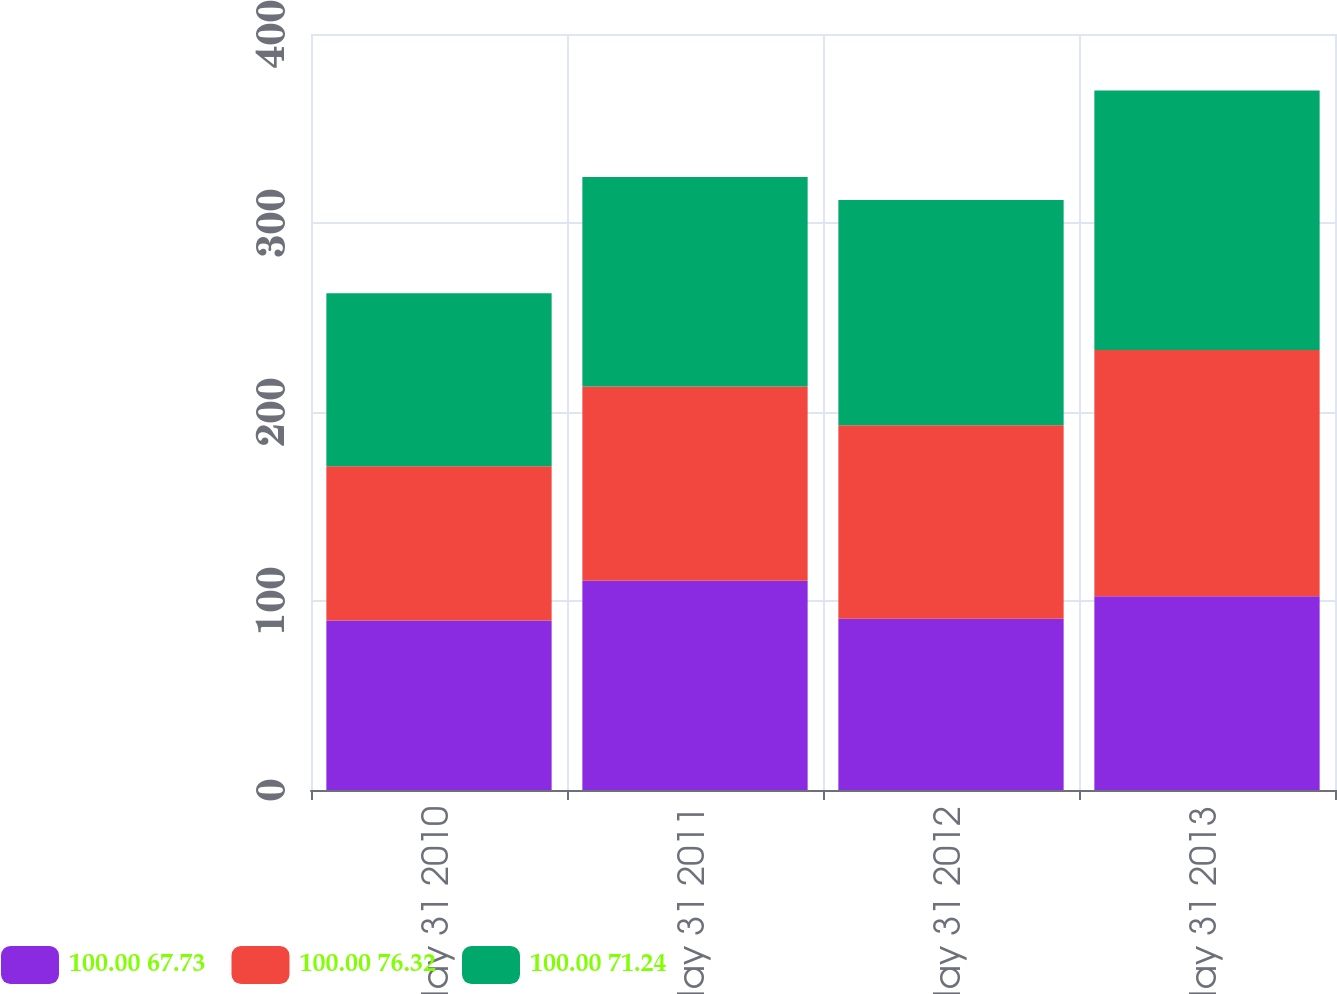Convert chart. <chart><loc_0><loc_0><loc_500><loc_500><stacked_bar_chart><ecel><fcel>May 31 2010<fcel>May 31 2011<fcel>May 31 2012<fcel>May 31 2013<nl><fcel>100.00 67.73<fcel>89.7<fcel>110.67<fcel>90.64<fcel>102.51<nl><fcel>100.00 76.32<fcel>81.58<fcel>102.76<fcel>102.33<fcel>130.24<nl><fcel>100.00 71.24<fcel>91.52<fcel>110.86<fcel>119.25<fcel>137.29<nl></chart> 